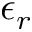<formula> <loc_0><loc_0><loc_500><loc_500>\epsilon _ { r }</formula> 